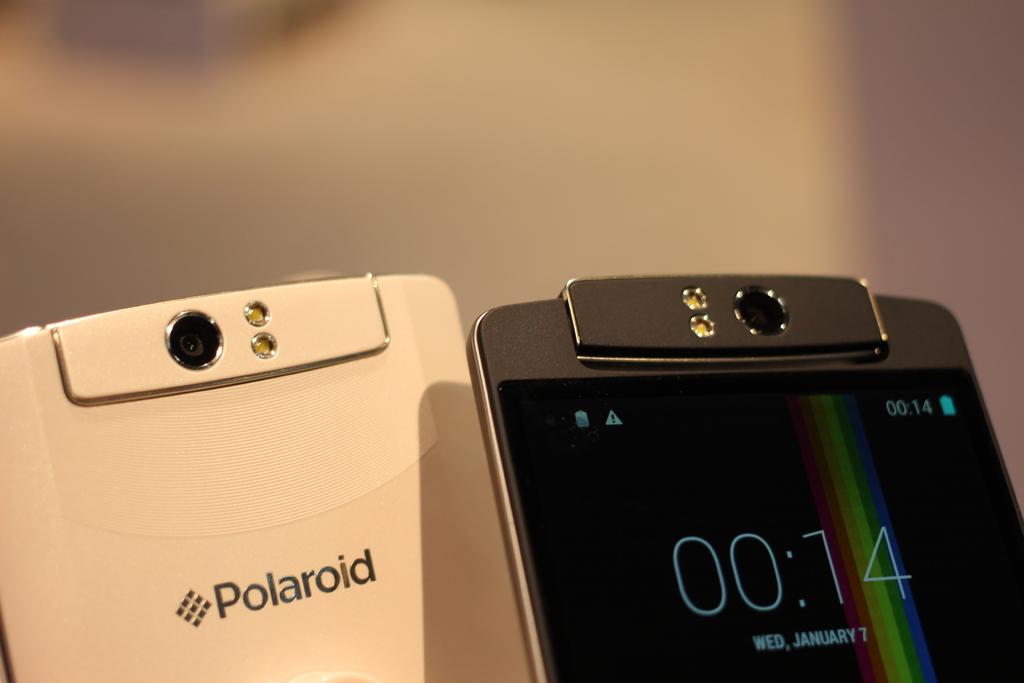What brand is this phone from?
Offer a very short reply. Polaroid. What is the date?
Provide a succinct answer. Wed, january 7. 